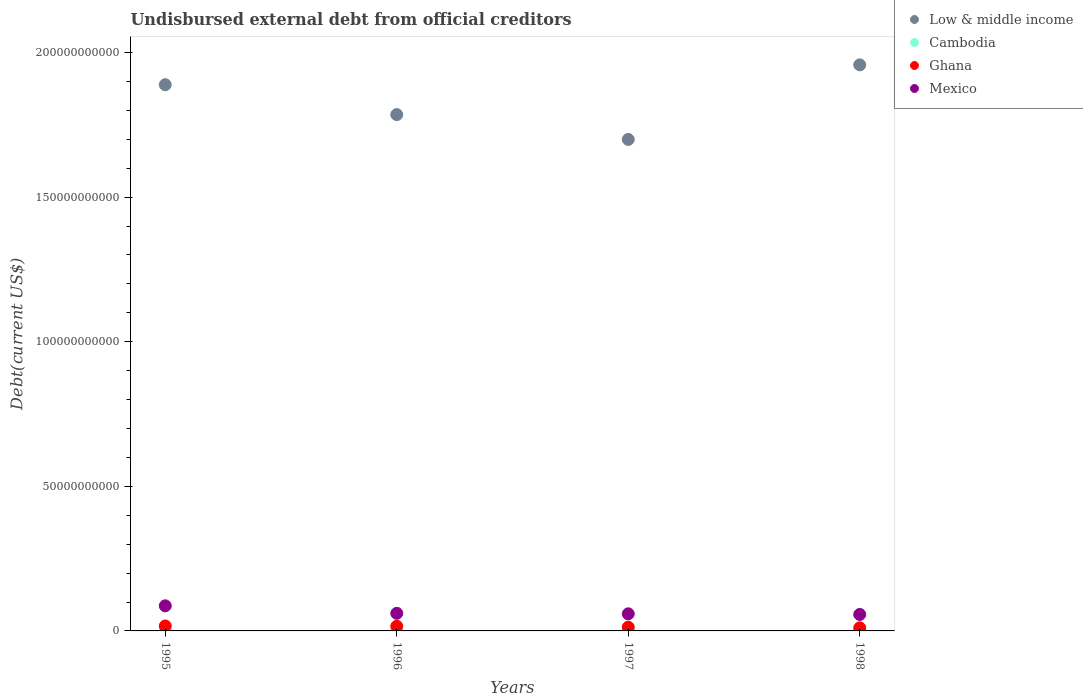How many different coloured dotlines are there?
Offer a terse response. 4. Is the number of dotlines equal to the number of legend labels?
Provide a short and direct response. Yes. What is the total debt in Cambodia in 1995?
Your response must be concise. 2.06e+08. Across all years, what is the maximum total debt in Mexico?
Your answer should be compact. 8.68e+09. Across all years, what is the minimum total debt in Cambodia?
Ensure brevity in your answer.  2.06e+08. What is the total total debt in Cambodia in the graph?
Offer a terse response. 8.67e+08. What is the difference between the total debt in Cambodia in 1995 and that in 1997?
Keep it short and to the point. -2.54e+07. What is the difference between the total debt in Low & middle income in 1995 and the total debt in Mexico in 1996?
Offer a terse response. 1.83e+11. What is the average total debt in Cambodia per year?
Make the answer very short. 2.17e+08. In the year 1998, what is the difference between the total debt in Mexico and total debt in Low & middle income?
Make the answer very short. -1.90e+11. What is the ratio of the total debt in Cambodia in 1996 to that in 1998?
Your response must be concise. 1.01. What is the difference between the highest and the second highest total debt in Low & middle income?
Your response must be concise. 6.87e+09. What is the difference between the highest and the lowest total debt in Cambodia?
Your answer should be compact. 2.54e+07. In how many years, is the total debt in Cambodia greater than the average total debt in Cambodia taken over all years?
Your answer should be compact. 1. Is the sum of the total debt in Cambodia in 1995 and 1998 greater than the maximum total debt in Ghana across all years?
Keep it short and to the point. No. Is it the case that in every year, the sum of the total debt in Ghana and total debt in Mexico  is greater than the sum of total debt in Low & middle income and total debt in Cambodia?
Your response must be concise. No. Does the total debt in Cambodia monotonically increase over the years?
Offer a very short reply. No. Is the total debt in Cambodia strictly greater than the total debt in Ghana over the years?
Your response must be concise. No. Is the total debt in Ghana strictly less than the total debt in Mexico over the years?
Your answer should be very brief. Yes. How many dotlines are there?
Your answer should be very brief. 4. What is the difference between two consecutive major ticks on the Y-axis?
Your answer should be compact. 5.00e+1. Are the values on the major ticks of Y-axis written in scientific E-notation?
Your answer should be compact. No. Does the graph contain any zero values?
Give a very brief answer. No. Does the graph contain grids?
Your response must be concise. No. Where does the legend appear in the graph?
Keep it short and to the point. Top right. What is the title of the graph?
Your answer should be compact. Undisbursed external debt from official creditors. Does "Belize" appear as one of the legend labels in the graph?
Provide a succinct answer. No. What is the label or title of the Y-axis?
Offer a very short reply. Debt(current US$). What is the Debt(current US$) of Low & middle income in 1995?
Offer a terse response. 1.89e+11. What is the Debt(current US$) of Cambodia in 1995?
Provide a short and direct response. 2.06e+08. What is the Debt(current US$) in Ghana in 1995?
Keep it short and to the point. 1.71e+09. What is the Debt(current US$) of Mexico in 1995?
Your answer should be very brief. 8.68e+09. What is the Debt(current US$) of Low & middle income in 1996?
Ensure brevity in your answer.  1.79e+11. What is the Debt(current US$) in Cambodia in 1996?
Your answer should be very brief. 2.16e+08. What is the Debt(current US$) in Ghana in 1996?
Provide a succinct answer. 1.61e+09. What is the Debt(current US$) in Mexico in 1996?
Give a very brief answer. 6.09e+09. What is the Debt(current US$) in Low & middle income in 1997?
Make the answer very short. 1.70e+11. What is the Debt(current US$) in Cambodia in 1997?
Keep it short and to the point. 2.31e+08. What is the Debt(current US$) in Ghana in 1997?
Offer a terse response. 1.29e+09. What is the Debt(current US$) of Mexico in 1997?
Your answer should be compact. 5.91e+09. What is the Debt(current US$) in Low & middle income in 1998?
Give a very brief answer. 1.96e+11. What is the Debt(current US$) of Cambodia in 1998?
Keep it short and to the point. 2.14e+08. What is the Debt(current US$) in Ghana in 1998?
Keep it short and to the point. 1.08e+09. What is the Debt(current US$) in Mexico in 1998?
Keep it short and to the point. 5.69e+09. Across all years, what is the maximum Debt(current US$) in Low & middle income?
Your response must be concise. 1.96e+11. Across all years, what is the maximum Debt(current US$) of Cambodia?
Your response must be concise. 2.31e+08. Across all years, what is the maximum Debt(current US$) in Ghana?
Ensure brevity in your answer.  1.71e+09. Across all years, what is the maximum Debt(current US$) of Mexico?
Offer a very short reply. 8.68e+09. Across all years, what is the minimum Debt(current US$) in Low & middle income?
Make the answer very short. 1.70e+11. Across all years, what is the minimum Debt(current US$) of Cambodia?
Make the answer very short. 2.06e+08. Across all years, what is the minimum Debt(current US$) of Ghana?
Give a very brief answer. 1.08e+09. Across all years, what is the minimum Debt(current US$) in Mexico?
Your answer should be compact. 5.69e+09. What is the total Debt(current US$) in Low & middle income in the graph?
Make the answer very short. 7.33e+11. What is the total Debt(current US$) of Cambodia in the graph?
Your response must be concise. 8.67e+08. What is the total Debt(current US$) of Ghana in the graph?
Offer a terse response. 5.68e+09. What is the total Debt(current US$) in Mexico in the graph?
Make the answer very short. 2.64e+1. What is the difference between the Debt(current US$) of Low & middle income in 1995 and that in 1996?
Provide a short and direct response. 1.03e+1. What is the difference between the Debt(current US$) in Cambodia in 1995 and that in 1996?
Offer a terse response. -1.07e+07. What is the difference between the Debt(current US$) in Ghana in 1995 and that in 1996?
Offer a terse response. 1.03e+08. What is the difference between the Debt(current US$) of Mexico in 1995 and that in 1996?
Provide a succinct answer. 2.59e+09. What is the difference between the Debt(current US$) of Low & middle income in 1995 and that in 1997?
Your response must be concise. 1.89e+1. What is the difference between the Debt(current US$) in Cambodia in 1995 and that in 1997?
Ensure brevity in your answer.  -2.54e+07. What is the difference between the Debt(current US$) of Ghana in 1995 and that in 1997?
Ensure brevity in your answer.  4.23e+08. What is the difference between the Debt(current US$) in Mexico in 1995 and that in 1997?
Provide a succinct answer. 2.77e+09. What is the difference between the Debt(current US$) in Low & middle income in 1995 and that in 1998?
Your response must be concise. -6.87e+09. What is the difference between the Debt(current US$) in Cambodia in 1995 and that in 1998?
Offer a terse response. -7.99e+06. What is the difference between the Debt(current US$) of Ghana in 1995 and that in 1998?
Keep it short and to the point. 6.36e+08. What is the difference between the Debt(current US$) of Mexico in 1995 and that in 1998?
Your answer should be compact. 2.99e+09. What is the difference between the Debt(current US$) of Low & middle income in 1996 and that in 1997?
Your answer should be very brief. 8.59e+09. What is the difference between the Debt(current US$) in Cambodia in 1996 and that in 1997?
Your answer should be compact. -1.47e+07. What is the difference between the Debt(current US$) of Ghana in 1996 and that in 1997?
Your answer should be very brief. 3.20e+08. What is the difference between the Debt(current US$) in Mexico in 1996 and that in 1997?
Your response must be concise. 1.75e+08. What is the difference between the Debt(current US$) in Low & middle income in 1996 and that in 1998?
Keep it short and to the point. -1.72e+1. What is the difference between the Debt(current US$) of Cambodia in 1996 and that in 1998?
Your answer should be very brief. 2.73e+06. What is the difference between the Debt(current US$) in Ghana in 1996 and that in 1998?
Make the answer very short. 5.32e+08. What is the difference between the Debt(current US$) in Mexico in 1996 and that in 1998?
Your answer should be very brief. 3.93e+08. What is the difference between the Debt(current US$) of Low & middle income in 1997 and that in 1998?
Give a very brief answer. -2.58e+1. What is the difference between the Debt(current US$) in Cambodia in 1997 and that in 1998?
Your answer should be compact. 1.74e+07. What is the difference between the Debt(current US$) of Ghana in 1997 and that in 1998?
Keep it short and to the point. 2.12e+08. What is the difference between the Debt(current US$) in Mexico in 1997 and that in 1998?
Offer a very short reply. 2.18e+08. What is the difference between the Debt(current US$) in Low & middle income in 1995 and the Debt(current US$) in Cambodia in 1996?
Your response must be concise. 1.89e+11. What is the difference between the Debt(current US$) in Low & middle income in 1995 and the Debt(current US$) in Ghana in 1996?
Make the answer very short. 1.87e+11. What is the difference between the Debt(current US$) in Low & middle income in 1995 and the Debt(current US$) in Mexico in 1996?
Offer a very short reply. 1.83e+11. What is the difference between the Debt(current US$) in Cambodia in 1995 and the Debt(current US$) in Ghana in 1996?
Provide a succinct answer. -1.40e+09. What is the difference between the Debt(current US$) in Cambodia in 1995 and the Debt(current US$) in Mexico in 1996?
Your response must be concise. -5.88e+09. What is the difference between the Debt(current US$) in Ghana in 1995 and the Debt(current US$) in Mexico in 1996?
Make the answer very short. -4.38e+09. What is the difference between the Debt(current US$) of Low & middle income in 1995 and the Debt(current US$) of Cambodia in 1997?
Your answer should be very brief. 1.89e+11. What is the difference between the Debt(current US$) in Low & middle income in 1995 and the Debt(current US$) in Ghana in 1997?
Your answer should be compact. 1.88e+11. What is the difference between the Debt(current US$) of Low & middle income in 1995 and the Debt(current US$) of Mexico in 1997?
Your answer should be very brief. 1.83e+11. What is the difference between the Debt(current US$) in Cambodia in 1995 and the Debt(current US$) in Ghana in 1997?
Make the answer very short. -1.08e+09. What is the difference between the Debt(current US$) of Cambodia in 1995 and the Debt(current US$) of Mexico in 1997?
Provide a succinct answer. -5.71e+09. What is the difference between the Debt(current US$) in Ghana in 1995 and the Debt(current US$) in Mexico in 1997?
Offer a very short reply. -4.20e+09. What is the difference between the Debt(current US$) in Low & middle income in 1995 and the Debt(current US$) in Cambodia in 1998?
Offer a terse response. 1.89e+11. What is the difference between the Debt(current US$) of Low & middle income in 1995 and the Debt(current US$) of Ghana in 1998?
Ensure brevity in your answer.  1.88e+11. What is the difference between the Debt(current US$) of Low & middle income in 1995 and the Debt(current US$) of Mexico in 1998?
Make the answer very short. 1.83e+11. What is the difference between the Debt(current US$) of Cambodia in 1995 and the Debt(current US$) of Ghana in 1998?
Provide a succinct answer. -8.69e+08. What is the difference between the Debt(current US$) in Cambodia in 1995 and the Debt(current US$) in Mexico in 1998?
Provide a succinct answer. -5.49e+09. What is the difference between the Debt(current US$) of Ghana in 1995 and the Debt(current US$) of Mexico in 1998?
Provide a short and direct response. -3.98e+09. What is the difference between the Debt(current US$) of Low & middle income in 1996 and the Debt(current US$) of Cambodia in 1997?
Your answer should be very brief. 1.78e+11. What is the difference between the Debt(current US$) in Low & middle income in 1996 and the Debt(current US$) in Ghana in 1997?
Give a very brief answer. 1.77e+11. What is the difference between the Debt(current US$) in Low & middle income in 1996 and the Debt(current US$) in Mexico in 1997?
Your response must be concise. 1.73e+11. What is the difference between the Debt(current US$) in Cambodia in 1996 and the Debt(current US$) in Ghana in 1997?
Your answer should be very brief. -1.07e+09. What is the difference between the Debt(current US$) of Cambodia in 1996 and the Debt(current US$) of Mexico in 1997?
Ensure brevity in your answer.  -5.70e+09. What is the difference between the Debt(current US$) of Ghana in 1996 and the Debt(current US$) of Mexico in 1997?
Provide a succinct answer. -4.30e+09. What is the difference between the Debt(current US$) in Low & middle income in 1996 and the Debt(current US$) in Cambodia in 1998?
Keep it short and to the point. 1.78e+11. What is the difference between the Debt(current US$) in Low & middle income in 1996 and the Debt(current US$) in Ghana in 1998?
Offer a terse response. 1.77e+11. What is the difference between the Debt(current US$) of Low & middle income in 1996 and the Debt(current US$) of Mexico in 1998?
Offer a terse response. 1.73e+11. What is the difference between the Debt(current US$) in Cambodia in 1996 and the Debt(current US$) in Ghana in 1998?
Provide a succinct answer. -8.59e+08. What is the difference between the Debt(current US$) of Cambodia in 1996 and the Debt(current US$) of Mexico in 1998?
Your answer should be compact. -5.48e+09. What is the difference between the Debt(current US$) of Ghana in 1996 and the Debt(current US$) of Mexico in 1998?
Your answer should be very brief. -4.09e+09. What is the difference between the Debt(current US$) of Low & middle income in 1997 and the Debt(current US$) of Cambodia in 1998?
Provide a succinct answer. 1.70e+11. What is the difference between the Debt(current US$) of Low & middle income in 1997 and the Debt(current US$) of Ghana in 1998?
Your answer should be compact. 1.69e+11. What is the difference between the Debt(current US$) in Low & middle income in 1997 and the Debt(current US$) in Mexico in 1998?
Your answer should be compact. 1.64e+11. What is the difference between the Debt(current US$) in Cambodia in 1997 and the Debt(current US$) in Ghana in 1998?
Ensure brevity in your answer.  -8.44e+08. What is the difference between the Debt(current US$) in Cambodia in 1997 and the Debt(current US$) in Mexico in 1998?
Your answer should be compact. -5.46e+09. What is the difference between the Debt(current US$) of Ghana in 1997 and the Debt(current US$) of Mexico in 1998?
Offer a terse response. -4.41e+09. What is the average Debt(current US$) in Low & middle income per year?
Your answer should be very brief. 1.83e+11. What is the average Debt(current US$) in Cambodia per year?
Keep it short and to the point. 2.17e+08. What is the average Debt(current US$) of Ghana per year?
Provide a short and direct response. 1.42e+09. What is the average Debt(current US$) of Mexico per year?
Ensure brevity in your answer.  6.59e+09. In the year 1995, what is the difference between the Debt(current US$) of Low & middle income and Debt(current US$) of Cambodia?
Provide a short and direct response. 1.89e+11. In the year 1995, what is the difference between the Debt(current US$) of Low & middle income and Debt(current US$) of Ghana?
Ensure brevity in your answer.  1.87e+11. In the year 1995, what is the difference between the Debt(current US$) in Low & middle income and Debt(current US$) in Mexico?
Your response must be concise. 1.80e+11. In the year 1995, what is the difference between the Debt(current US$) in Cambodia and Debt(current US$) in Ghana?
Give a very brief answer. -1.50e+09. In the year 1995, what is the difference between the Debt(current US$) of Cambodia and Debt(current US$) of Mexico?
Give a very brief answer. -8.48e+09. In the year 1995, what is the difference between the Debt(current US$) of Ghana and Debt(current US$) of Mexico?
Your answer should be compact. -6.97e+09. In the year 1996, what is the difference between the Debt(current US$) in Low & middle income and Debt(current US$) in Cambodia?
Offer a terse response. 1.78e+11. In the year 1996, what is the difference between the Debt(current US$) in Low & middle income and Debt(current US$) in Ghana?
Ensure brevity in your answer.  1.77e+11. In the year 1996, what is the difference between the Debt(current US$) in Low & middle income and Debt(current US$) in Mexico?
Provide a succinct answer. 1.72e+11. In the year 1996, what is the difference between the Debt(current US$) of Cambodia and Debt(current US$) of Ghana?
Ensure brevity in your answer.  -1.39e+09. In the year 1996, what is the difference between the Debt(current US$) in Cambodia and Debt(current US$) in Mexico?
Give a very brief answer. -5.87e+09. In the year 1996, what is the difference between the Debt(current US$) of Ghana and Debt(current US$) of Mexico?
Offer a terse response. -4.48e+09. In the year 1997, what is the difference between the Debt(current US$) in Low & middle income and Debt(current US$) in Cambodia?
Make the answer very short. 1.70e+11. In the year 1997, what is the difference between the Debt(current US$) in Low & middle income and Debt(current US$) in Ghana?
Give a very brief answer. 1.69e+11. In the year 1997, what is the difference between the Debt(current US$) of Low & middle income and Debt(current US$) of Mexico?
Offer a terse response. 1.64e+11. In the year 1997, what is the difference between the Debt(current US$) in Cambodia and Debt(current US$) in Ghana?
Keep it short and to the point. -1.06e+09. In the year 1997, what is the difference between the Debt(current US$) in Cambodia and Debt(current US$) in Mexico?
Offer a terse response. -5.68e+09. In the year 1997, what is the difference between the Debt(current US$) of Ghana and Debt(current US$) of Mexico?
Your answer should be very brief. -4.62e+09. In the year 1998, what is the difference between the Debt(current US$) in Low & middle income and Debt(current US$) in Cambodia?
Offer a very short reply. 1.96e+11. In the year 1998, what is the difference between the Debt(current US$) of Low & middle income and Debt(current US$) of Ghana?
Make the answer very short. 1.95e+11. In the year 1998, what is the difference between the Debt(current US$) in Low & middle income and Debt(current US$) in Mexico?
Your answer should be very brief. 1.90e+11. In the year 1998, what is the difference between the Debt(current US$) in Cambodia and Debt(current US$) in Ghana?
Provide a succinct answer. -8.61e+08. In the year 1998, what is the difference between the Debt(current US$) in Cambodia and Debt(current US$) in Mexico?
Ensure brevity in your answer.  -5.48e+09. In the year 1998, what is the difference between the Debt(current US$) of Ghana and Debt(current US$) of Mexico?
Your answer should be very brief. -4.62e+09. What is the ratio of the Debt(current US$) of Low & middle income in 1995 to that in 1996?
Offer a terse response. 1.06. What is the ratio of the Debt(current US$) of Cambodia in 1995 to that in 1996?
Provide a short and direct response. 0.95. What is the ratio of the Debt(current US$) in Ghana in 1995 to that in 1996?
Your response must be concise. 1.06. What is the ratio of the Debt(current US$) in Mexico in 1995 to that in 1996?
Ensure brevity in your answer.  1.43. What is the ratio of the Debt(current US$) in Low & middle income in 1995 to that in 1997?
Provide a succinct answer. 1.11. What is the ratio of the Debt(current US$) in Cambodia in 1995 to that in 1997?
Offer a very short reply. 0.89. What is the ratio of the Debt(current US$) of Ghana in 1995 to that in 1997?
Make the answer very short. 1.33. What is the ratio of the Debt(current US$) of Mexico in 1995 to that in 1997?
Your response must be concise. 1.47. What is the ratio of the Debt(current US$) in Low & middle income in 1995 to that in 1998?
Your answer should be very brief. 0.96. What is the ratio of the Debt(current US$) of Cambodia in 1995 to that in 1998?
Offer a very short reply. 0.96. What is the ratio of the Debt(current US$) in Ghana in 1995 to that in 1998?
Your answer should be very brief. 1.59. What is the ratio of the Debt(current US$) in Mexico in 1995 to that in 1998?
Make the answer very short. 1.52. What is the ratio of the Debt(current US$) in Low & middle income in 1996 to that in 1997?
Give a very brief answer. 1.05. What is the ratio of the Debt(current US$) of Cambodia in 1996 to that in 1997?
Provide a succinct answer. 0.94. What is the ratio of the Debt(current US$) in Ghana in 1996 to that in 1997?
Ensure brevity in your answer.  1.25. What is the ratio of the Debt(current US$) of Mexico in 1996 to that in 1997?
Your answer should be very brief. 1.03. What is the ratio of the Debt(current US$) of Low & middle income in 1996 to that in 1998?
Keep it short and to the point. 0.91. What is the ratio of the Debt(current US$) of Cambodia in 1996 to that in 1998?
Your response must be concise. 1.01. What is the ratio of the Debt(current US$) in Ghana in 1996 to that in 1998?
Offer a terse response. 1.5. What is the ratio of the Debt(current US$) in Mexico in 1996 to that in 1998?
Give a very brief answer. 1.07. What is the ratio of the Debt(current US$) of Low & middle income in 1997 to that in 1998?
Make the answer very short. 0.87. What is the ratio of the Debt(current US$) in Cambodia in 1997 to that in 1998?
Give a very brief answer. 1.08. What is the ratio of the Debt(current US$) in Ghana in 1997 to that in 1998?
Your answer should be compact. 1.2. What is the ratio of the Debt(current US$) in Mexico in 1997 to that in 1998?
Your response must be concise. 1.04. What is the difference between the highest and the second highest Debt(current US$) of Low & middle income?
Give a very brief answer. 6.87e+09. What is the difference between the highest and the second highest Debt(current US$) in Cambodia?
Provide a short and direct response. 1.47e+07. What is the difference between the highest and the second highest Debt(current US$) of Ghana?
Provide a short and direct response. 1.03e+08. What is the difference between the highest and the second highest Debt(current US$) of Mexico?
Ensure brevity in your answer.  2.59e+09. What is the difference between the highest and the lowest Debt(current US$) of Low & middle income?
Your response must be concise. 2.58e+1. What is the difference between the highest and the lowest Debt(current US$) of Cambodia?
Offer a terse response. 2.54e+07. What is the difference between the highest and the lowest Debt(current US$) of Ghana?
Provide a short and direct response. 6.36e+08. What is the difference between the highest and the lowest Debt(current US$) of Mexico?
Provide a succinct answer. 2.99e+09. 